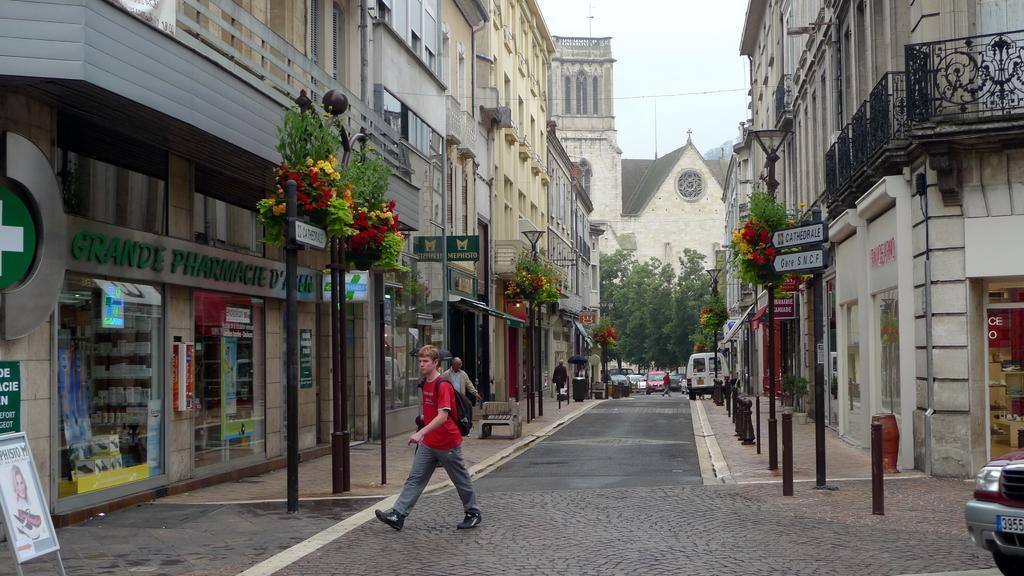Please provide a concise description of this image. In this picture there is a man who is wearing red t-shirt, trouser and bag. He is walking on the street, beside him there is a pole on which we can see some flowers and plants. In the back we can see building, cars, vehicles, persons and monument. At the top there is a sky. At the bottom left there is a board. On the right there is a sign board near to the wall. 